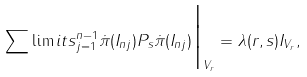<formula> <loc_0><loc_0><loc_500><loc_500>\sum \lim i t s _ { j = 1 } ^ { n - 1 } \dot { \pi } ( I _ { n j } ) P _ { s } \dot { \pi } ( I _ { n j } ) \Big | _ { V _ { r } } = \lambda ( r , s ) I _ { V _ { r } } ,</formula> 